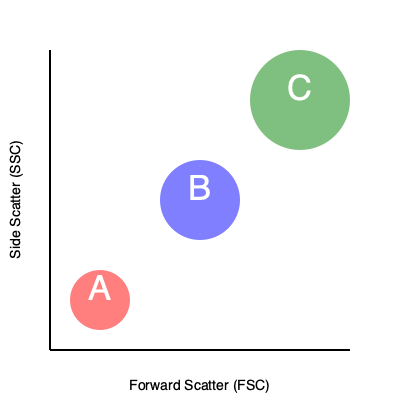Analyze the flow cytometry scatter plot showing three distinct cell populations (A, B, and C) at different stages of stem cell differentiation. Based on the forward scatter (FSC) and side scatter (SSC) characteristics, which population is most likely to represent the most differentiated cells, and why? To identify the most differentiated cells in this flow cytometry scatter plot, we need to consider the following steps:

1. Understand the axes:
   - X-axis: Forward Scatter (FSC) - indicates cell size
   - Y-axis: Side Scatter (SSC) - indicates cell complexity or granularity

2. Analyze the characteristics of each population:
   - Population A: Low FSC, low SSC
   - Population B: Medium FSC, medium SSC
   - Population C: High FSC, high SSC

3. Consider the relationship between differentiation and cell characteristics:
   - As stem cells differentiate, they typically:
     a. Increase in size (higher FSC)
     b. Become more complex with specialized structures (higher SSC)

4. Compare the populations:
   - Population A: Smallest and least complex, likely undifferentiated stem cells
   - Population B: Intermediate size and complexity, possibly partially differentiated cells
   - Population C: Largest and most complex, indicative of the most differentiated cells

5. Conclusion:
   Population C exhibits the highest FSC and SSC values, suggesting these cells are the largest and most complex. These characteristics are consistent with the most differentiated cells in the sample.
Answer: Population C 